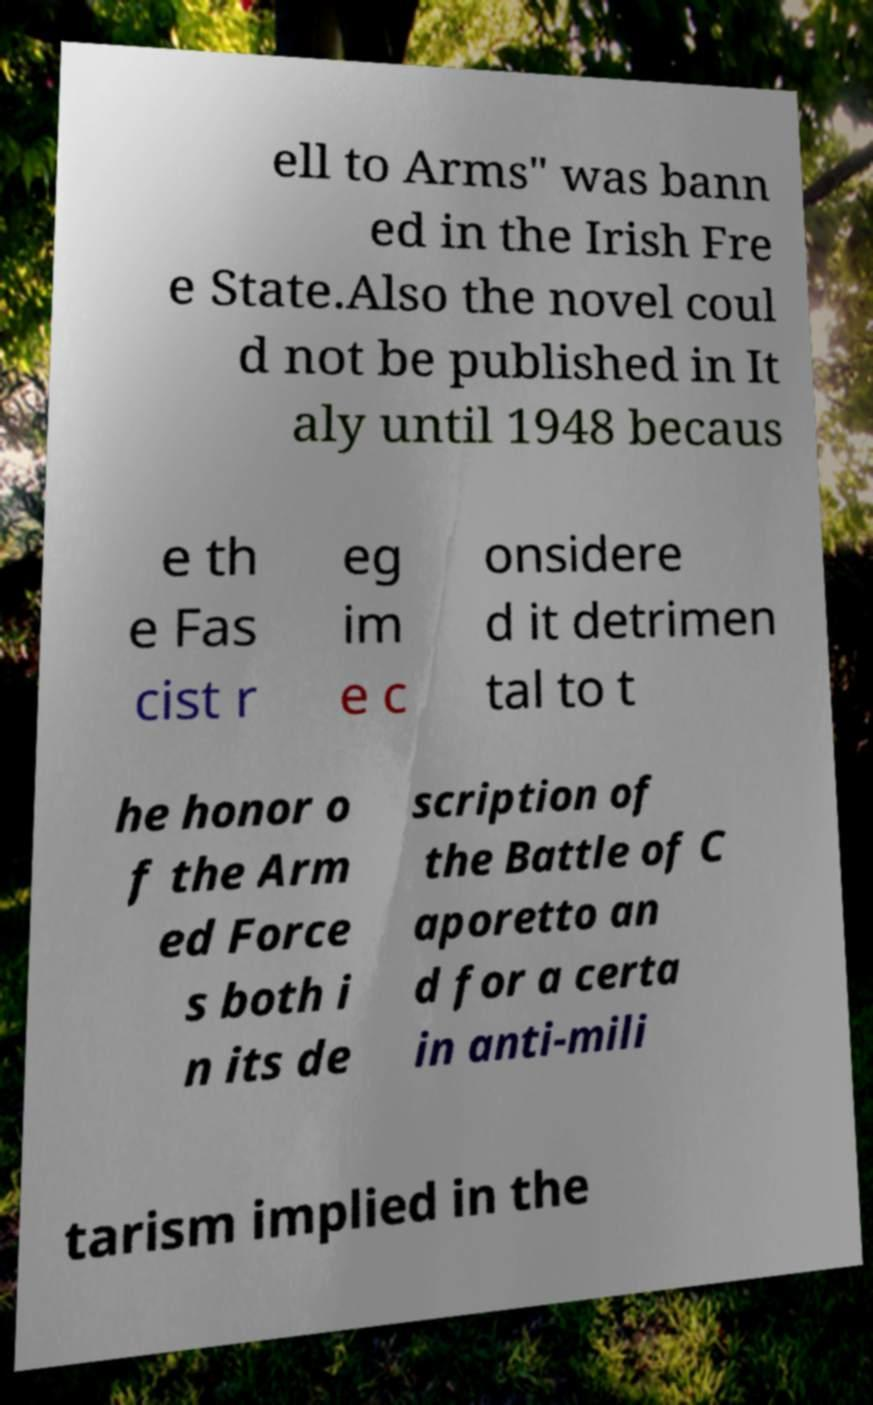Could you extract and type out the text from this image? ell to Arms" was bann ed in the Irish Fre e State.Also the novel coul d not be published in It aly until 1948 becaus e th e Fas cist r eg im e c onsidere d it detrimen tal to t he honor o f the Arm ed Force s both i n its de scription of the Battle of C aporetto an d for a certa in anti-mili tarism implied in the 